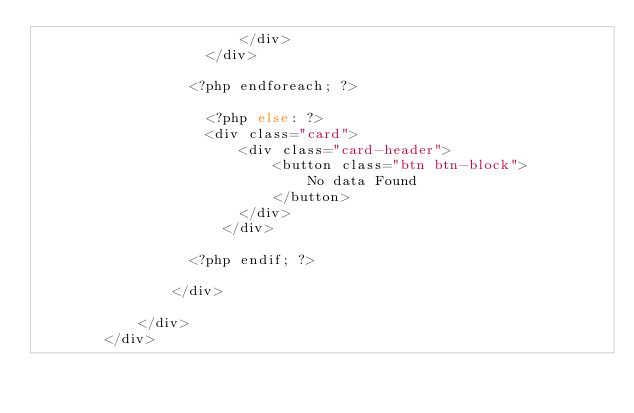<code> <loc_0><loc_0><loc_500><loc_500><_PHP_>                        </div>
                    </div>

                  <?php endforeach; ?>

                    <?php else: ?>
                    <div class="card">
                        <div class="card-header">
                            <button class="btn btn-block">
                                No data Found
                            </button>
                        </div>
                      </div>

                  <?php endif; ?>

                </div>

            </div>
        </div>
</code> 